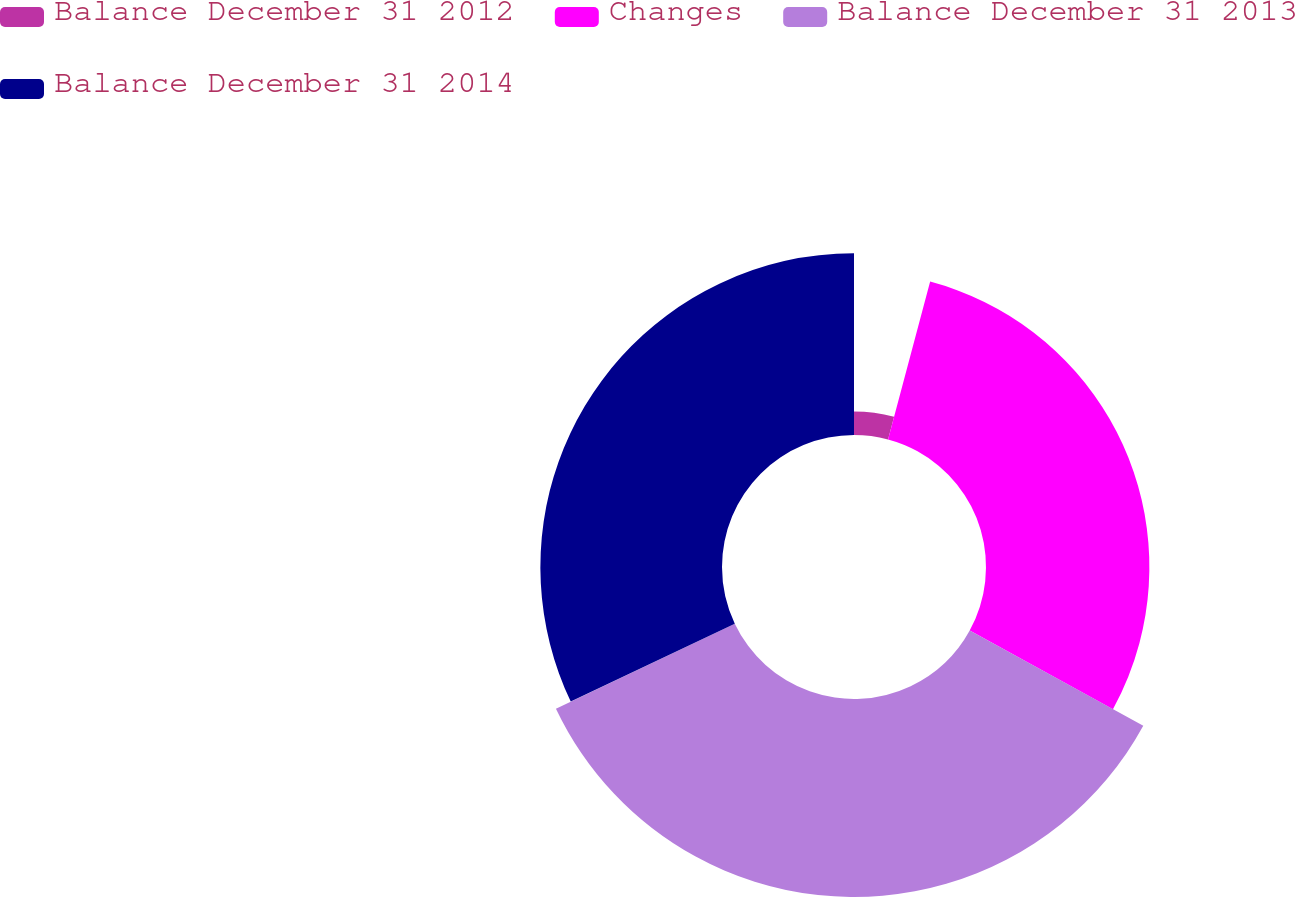Convert chart to OTSL. <chart><loc_0><loc_0><loc_500><loc_500><pie_chart><fcel>Balance December 31 2012<fcel>Changes<fcel>Balance December 31 2013<fcel>Balance December 31 2014<nl><fcel>4.15%<fcel>28.84%<fcel>34.95%<fcel>32.06%<nl></chart> 